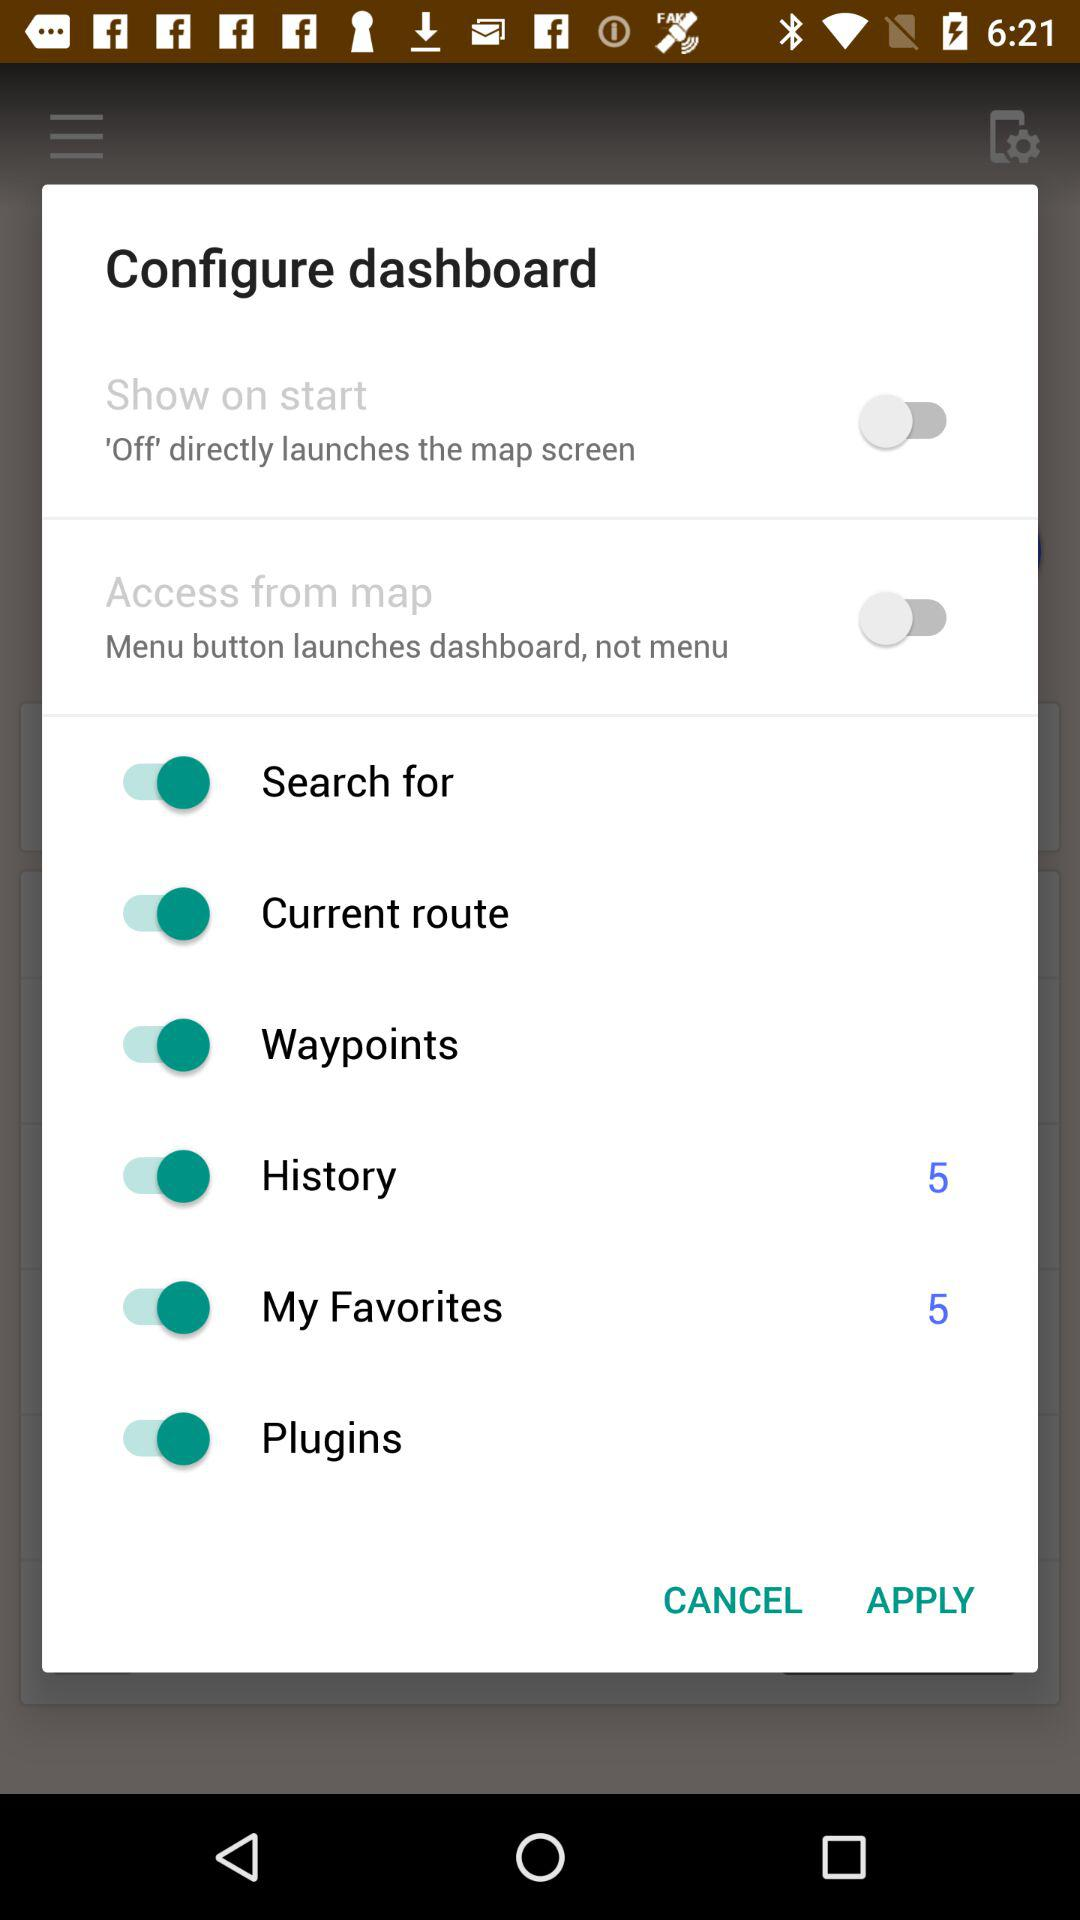What is the status of "Plugins"? The status is "on". 